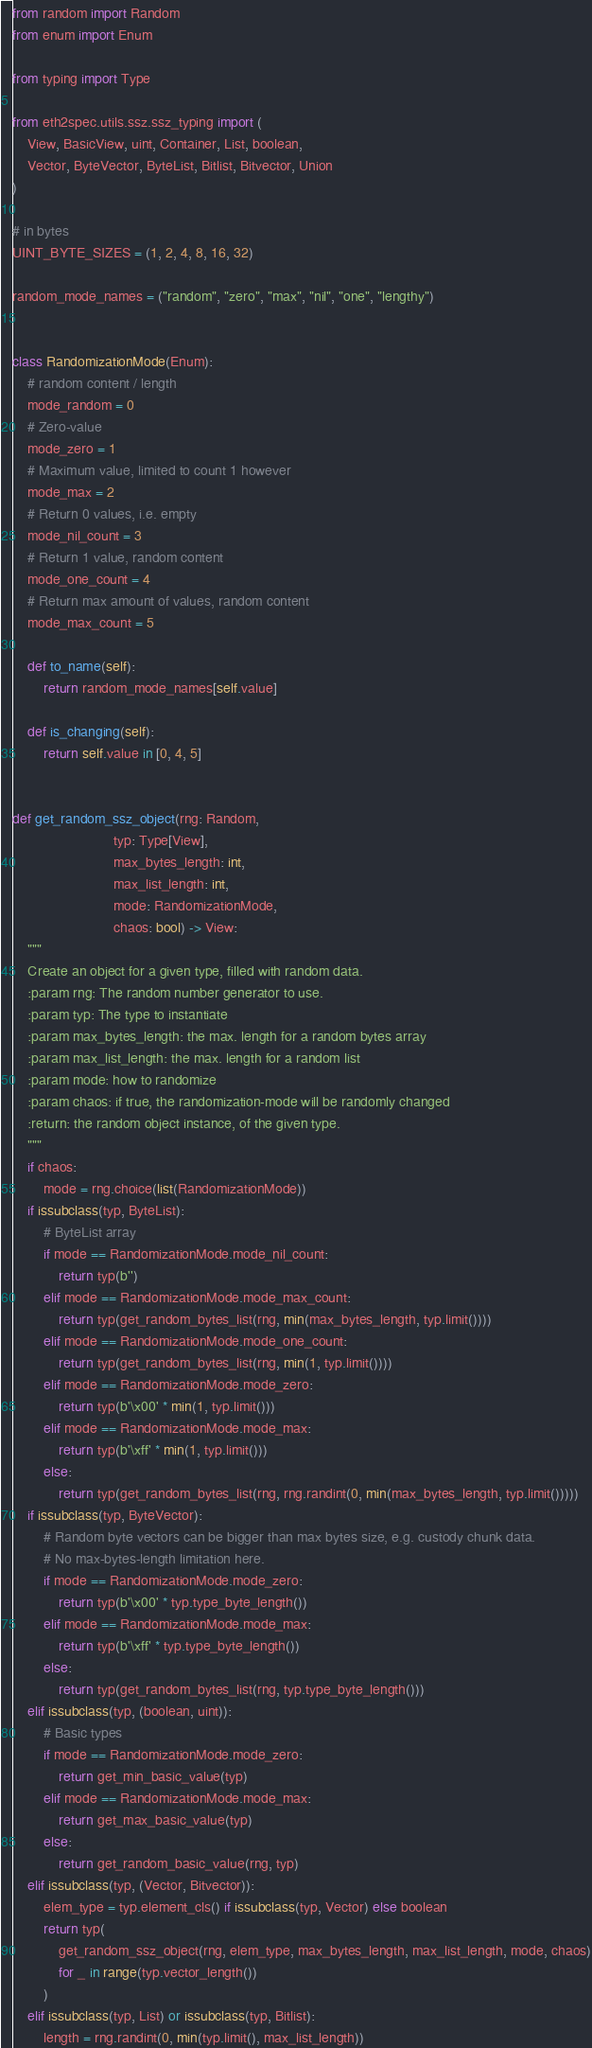Convert code to text. <code><loc_0><loc_0><loc_500><loc_500><_Python_>from random import Random
from enum import Enum

from typing import Type

from eth2spec.utils.ssz.ssz_typing import (
    View, BasicView, uint, Container, List, boolean,
    Vector, ByteVector, ByteList, Bitlist, Bitvector, Union
)

# in bytes
UINT_BYTE_SIZES = (1, 2, 4, 8, 16, 32)

random_mode_names = ("random", "zero", "max", "nil", "one", "lengthy")


class RandomizationMode(Enum):
    # random content / length
    mode_random = 0
    # Zero-value
    mode_zero = 1
    # Maximum value, limited to count 1 however
    mode_max = 2
    # Return 0 values, i.e. empty
    mode_nil_count = 3
    # Return 1 value, random content
    mode_one_count = 4
    # Return max amount of values, random content
    mode_max_count = 5

    def to_name(self):
        return random_mode_names[self.value]

    def is_changing(self):
        return self.value in [0, 4, 5]


def get_random_ssz_object(rng: Random,
                          typ: Type[View],
                          max_bytes_length: int,
                          max_list_length: int,
                          mode: RandomizationMode,
                          chaos: bool) -> View:
    """
    Create an object for a given type, filled with random data.
    :param rng: The random number generator to use.
    :param typ: The type to instantiate
    :param max_bytes_length: the max. length for a random bytes array
    :param max_list_length: the max. length for a random list
    :param mode: how to randomize
    :param chaos: if true, the randomization-mode will be randomly changed
    :return: the random object instance, of the given type.
    """
    if chaos:
        mode = rng.choice(list(RandomizationMode))
    if issubclass(typ, ByteList):
        # ByteList array
        if mode == RandomizationMode.mode_nil_count:
            return typ(b'')
        elif mode == RandomizationMode.mode_max_count:
            return typ(get_random_bytes_list(rng, min(max_bytes_length, typ.limit())))
        elif mode == RandomizationMode.mode_one_count:
            return typ(get_random_bytes_list(rng, min(1, typ.limit())))
        elif mode == RandomizationMode.mode_zero:
            return typ(b'\x00' * min(1, typ.limit()))
        elif mode == RandomizationMode.mode_max:
            return typ(b'\xff' * min(1, typ.limit()))
        else:
            return typ(get_random_bytes_list(rng, rng.randint(0, min(max_bytes_length, typ.limit()))))
    if issubclass(typ, ByteVector):
        # Random byte vectors can be bigger than max bytes size, e.g. custody chunk data.
        # No max-bytes-length limitation here.
        if mode == RandomizationMode.mode_zero:
            return typ(b'\x00' * typ.type_byte_length())
        elif mode == RandomizationMode.mode_max:
            return typ(b'\xff' * typ.type_byte_length())
        else:
            return typ(get_random_bytes_list(rng, typ.type_byte_length()))
    elif issubclass(typ, (boolean, uint)):
        # Basic types
        if mode == RandomizationMode.mode_zero:
            return get_min_basic_value(typ)
        elif mode == RandomizationMode.mode_max:
            return get_max_basic_value(typ)
        else:
            return get_random_basic_value(rng, typ)
    elif issubclass(typ, (Vector, Bitvector)):
        elem_type = typ.element_cls() if issubclass(typ, Vector) else boolean
        return typ(
            get_random_ssz_object(rng, elem_type, max_bytes_length, max_list_length, mode, chaos)
            for _ in range(typ.vector_length())
        )
    elif issubclass(typ, List) or issubclass(typ, Bitlist):
        length = rng.randint(0, min(typ.limit(), max_list_length))</code> 